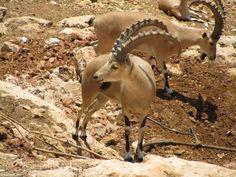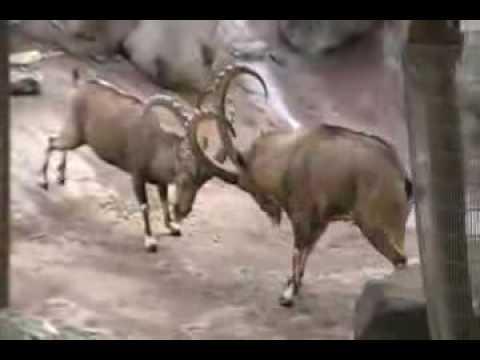The first image is the image on the left, the second image is the image on the right. Evaluate the accuracy of this statement regarding the images: "There is exactly two mountain goats in the right image.". Is it true? Answer yes or no. Yes. 